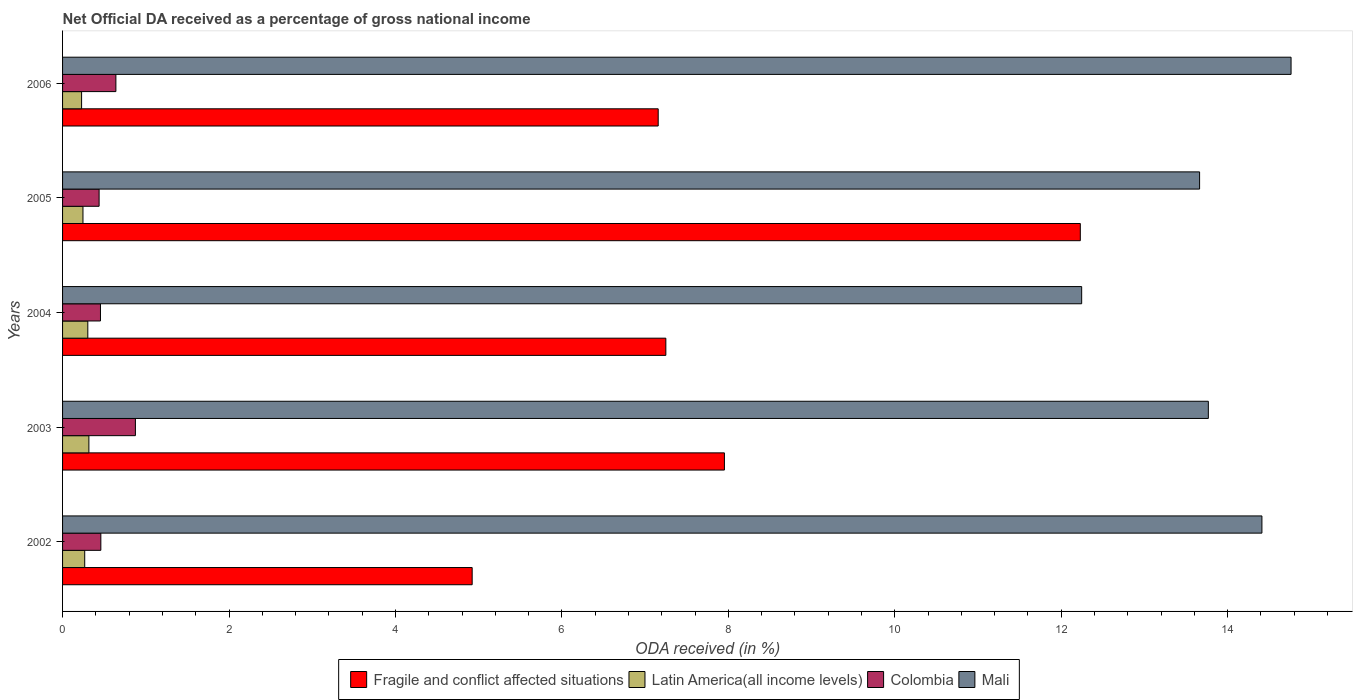Are the number of bars on each tick of the Y-axis equal?
Offer a very short reply. Yes. How many bars are there on the 2nd tick from the bottom?
Ensure brevity in your answer.  4. What is the net official DA received in Latin America(all income levels) in 2006?
Provide a succinct answer. 0.23. Across all years, what is the maximum net official DA received in Colombia?
Your answer should be compact. 0.88. Across all years, what is the minimum net official DA received in Fragile and conflict affected situations?
Provide a short and direct response. 4.92. In which year was the net official DA received in Mali maximum?
Offer a terse response. 2006. What is the total net official DA received in Fragile and conflict affected situations in the graph?
Your response must be concise. 39.51. What is the difference between the net official DA received in Fragile and conflict affected situations in 2004 and that in 2005?
Offer a very short reply. -4.98. What is the difference between the net official DA received in Mali in 2004 and the net official DA received in Fragile and conflict affected situations in 2002?
Your answer should be very brief. 7.32. What is the average net official DA received in Latin America(all income levels) per year?
Make the answer very short. 0.27. In the year 2003, what is the difference between the net official DA received in Mali and net official DA received in Colombia?
Offer a terse response. 12.89. What is the ratio of the net official DA received in Colombia in 2003 to that in 2006?
Give a very brief answer. 1.37. Is the net official DA received in Mali in 2004 less than that in 2005?
Keep it short and to the point. Yes. What is the difference between the highest and the second highest net official DA received in Latin America(all income levels)?
Make the answer very short. 0.01. What is the difference between the highest and the lowest net official DA received in Fragile and conflict affected situations?
Keep it short and to the point. 7.31. In how many years, is the net official DA received in Colombia greater than the average net official DA received in Colombia taken over all years?
Keep it short and to the point. 2. What does the 4th bar from the top in 2002 represents?
Your answer should be compact. Fragile and conflict affected situations. What does the 3rd bar from the bottom in 2002 represents?
Provide a short and direct response. Colombia. Is it the case that in every year, the sum of the net official DA received in Fragile and conflict affected situations and net official DA received in Colombia is greater than the net official DA received in Latin America(all income levels)?
Make the answer very short. Yes. How many bars are there?
Offer a very short reply. 20. Are all the bars in the graph horizontal?
Your answer should be very brief. Yes. Does the graph contain any zero values?
Keep it short and to the point. No. Where does the legend appear in the graph?
Give a very brief answer. Bottom center. How many legend labels are there?
Your answer should be very brief. 4. How are the legend labels stacked?
Offer a very short reply. Horizontal. What is the title of the graph?
Offer a terse response. Net Official DA received as a percentage of gross national income. Does "Cyprus" appear as one of the legend labels in the graph?
Offer a very short reply. No. What is the label or title of the X-axis?
Ensure brevity in your answer.  ODA received (in %). What is the ODA received (in %) of Fragile and conflict affected situations in 2002?
Make the answer very short. 4.92. What is the ODA received (in %) of Latin America(all income levels) in 2002?
Provide a succinct answer. 0.27. What is the ODA received (in %) of Colombia in 2002?
Provide a succinct answer. 0.46. What is the ODA received (in %) in Mali in 2002?
Make the answer very short. 14.41. What is the ODA received (in %) of Fragile and conflict affected situations in 2003?
Keep it short and to the point. 7.95. What is the ODA received (in %) in Latin America(all income levels) in 2003?
Your answer should be compact. 0.32. What is the ODA received (in %) of Colombia in 2003?
Provide a short and direct response. 0.88. What is the ODA received (in %) in Mali in 2003?
Keep it short and to the point. 13.77. What is the ODA received (in %) in Fragile and conflict affected situations in 2004?
Make the answer very short. 7.25. What is the ODA received (in %) in Latin America(all income levels) in 2004?
Offer a very short reply. 0.3. What is the ODA received (in %) of Colombia in 2004?
Your response must be concise. 0.46. What is the ODA received (in %) of Mali in 2004?
Offer a terse response. 12.25. What is the ODA received (in %) in Fragile and conflict affected situations in 2005?
Make the answer very short. 12.23. What is the ODA received (in %) of Latin America(all income levels) in 2005?
Your answer should be very brief. 0.25. What is the ODA received (in %) in Colombia in 2005?
Your response must be concise. 0.44. What is the ODA received (in %) in Mali in 2005?
Your answer should be very brief. 13.66. What is the ODA received (in %) of Fragile and conflict affected situations in 2006?
Your answer should be very brief. 7.16. What is the ODA received (in %) of Latin America(all income levels) in 2006?
Offer a terse response. 0.23. What is the ODA received (in %) in Colombia in 2006?
Provide a short and direct response. 0.64. What is the ODA received (in %) in Mali in 2006?
Offer a terse response. 14.76. Across all years, what is the maximum ODA received (in %) in Fragile and conflict affected situations?
Give a very brief answer. 12.23. Across all years, what is the maximum ODA received (in %) of Latin America(all income levels)?
Your response must be concise. 0.32. Across all years, what is the maximum ODA received (in %) in Colombia?
Your answer should be compact. 0.88. Across all years, what is the maximum ODA received (in %) in Mali?
Offer a very short reply. 14.76. Across all years, what is the minimum ODA received (in %) in Fragile and conflict affected situations?
Offer a terse response. 4.92. Across all years, what is the minimum ODA received (in %) of Latin America(all income levels)?
Make the answer very short. 0.23. Across all years, what is the minimum ODA received (in %) in Colombia?
Provide a succinct answer. 0.44. Across all years, what is the minimum ODA received (in %) of Mali?
Make the answer very short. 12.25. What is the total ODA received (in %) of Fragile and conflict affected situations in the graph?
Your answer should be very brief. 39.51. What is the total ODA received (in %) of Latin America(all income levels) in the graph?
Your answer should be compact. 1.36. What is the total ODA received (in %) of Colombia in the graph?
Your response must be concise. 2.87. What is the total ODA received (in %) of Mali in the graph?
Provide a succinct answer. 68.85. What is the difference between the ODA received (in %) of Fragile and conflict affected situations in 2002 and that in 2003?
Your response must be concise. -3.03. What is the difference between the ODA received (in %) of Latin America(all income levels) in 2002 and that in 2003?
Provide a succinct answer. -0.05. What is the difference between the ODA received (in %) in Colombia in 2002 and that in 2003?
Your answer should be compact. -0.42. What is the difference between the ODA received (in %) of Mali in 2002 and that in 2003?
Make the answer very short. 0.64. What is the difference between the ODA received (in %) of Fragile and conflict affected situations in 2002 and that in 2004?
Keep it short and to the point. -2.33. What is the difference between the ODA received (in %) in Latin America(all income levels) in 2002 and that in 2004?
Your answer should be very brief. -0.04. What is the difference between the ODA received (in %) of Colombia in 2002 and that in 2004?
Your answer should be very brief. 0. What is the difference between the ODA received (in %) of Mali in 2002 and that in 2004?
Provide a succinct answer. 2.17. What is the difference between the ODA received (in %) of Fragile and conflict affected situations in 2002 and that in 2005?
Keep it short and to the point. -7.31. What is the difference between the ODA received (in %) in Latin America(all income levels) in 2002 and that in 2005?
Keep it short and to the point. 0.02. What is the difference between the ODA received (in %) in Colombia in 2002 and that in 2005?
Your answer should be very brief. 0.02. What is the difference between the ODA received (in %) of Mali in 2002 and that in 2005?
Your answer should be compact. 0.75. What is the difference between the ODA received (in %) in Fragile and conflict affected situations in 2002 and that in 2006?
Keep it short and to the point. -2.24. What is the difference between the ODA received (in %) of Latin America(all income levels) in 2002 and that in 2006?
Give a very brief answer. 0.04. What is the difference between the ODA received (in %) in Colombia in 2002 and that in 2006?
Ensure brevity in your answer.  -0.18. What is the difference between the ODA received (in %) of Mali in 2002 and that in 2006?
Keep it short and to the point. -0.35. What is the difference between the ODA received (in %) in Fragile and conflict affected situations in 2003 and that in 2004?
Offer a very short reply. 0.7. What is the difference between the ODA received (in %) of Latin America(all income levels) in 2003 and that in 2004?
Keep it short and to the point. 0.01. What is the difference between the ODA received (in %) of Colombia in 2003 and that in 2004?
Offer a terse response. 0.42. What is the difference between the ODA received (in %) of Mali in 2003 and that in 2004?
Provide a succinct answer. 1.52. What is the difference between the ODA received (in %) of Fragile and conflict affected situations in 2003 and that in 2005?
Your response must be concise. -4.28. What is the difference between the ODA received (in %) in Latin America(all income levels) in 2003 and that in 2005?
Ensure brevity in your answer.  0.07. What is the difference between the ODA received (in %) in Colombia in 2003 and that in 2005?
Your response must be concise. 0.44. What is the difference between the ODA received (in %) of Mali in 2003 and that in 2005?
Provide a succinct answer. 0.11. What is the difference between the ODA received (in %) in Fragile and conflict affected situations in 2003 and that in 2006?
Make the answer very short. 0.8. What is the difference between the ODA received (in %) in Latin America(all income levels) in 2003 and that in 2006?
Make the answer very short. 0.09. What is the difference between the ODA received (in %) in Colombia in 2003 and that in 2006?
Provide a succinct answer. 0.23. What is the difference between the ODA received (in %) in Mali in 2003 and that in 2006?
Your answer should be compact. -0.99. What is the difference between the ODA received (in %) in Fragile and conflict affected situations in 2004 and that in 2005?
Ensure brevity in your answer.  -4.98. What is the difference between the ODA received (in %) of Latin America(all income levels) in 2004 and that in 2005?
Offer a terse response. 0.06. What is the difference between the ODA received (in %) of Colombia in 2004 and that in 2005?
Give a very brief answer. 0.02. What is the difference between the ODA received (in %) in Mali in 2004 and that in 2005?
Provide a short and direct response. -1.42. What is the difference between the ODA received (in %) in Fragile and conflict affected situations in 2004 and that in 2006?
Your response must be concise. 0.09. What is the difference between the ODA received (in %) of Latin America(all income levels) in 2004 and that in 2006?
Provide a succinct answer. 0.07. What is the difference between the ODA received (in %) of Colombia in 2004 and that in 2006?
Your answer should be compact. -0.19. What is the difference between the ODA received (in %) in Mali in 2004 and that in 2006?
Your answer should be compact. -2.52. What is the difference between the ODA received (in %) in Fragile and conflict affected situations in 2005 and that in 2006?
Provide a short and direct response. 5.07. What is the difference between the ODA received (in %) of Latin America(all income levels) in 2005 and that in 2006?
Keep it short and to the point. 0.02. What is the difference between the ODA received (in %) in Colombia in 2005 and that in 2006?
Offer a terse response. -0.2. What is the difference between the ODA received (in %) of Mali in 2005 and that in 2006?
Provide a succinct answer. -1.1. What is the difference between the ODA received (in %) in Fragile and conflict affected situations in 2002 and the ODA received (in %) in Latin America(all income levels) in 2003?
Your answer should be compact. 4.61. What is the difference between the ODA received (in %) of Fragile and conflict affected situations in 2002 and the ODA received (in %) of Colombia in 2003?
Your answer should be very brief. 4.05. What is the difference between the ODA received (in %) of Fragile and conflict affected situations in 2002 and the ODA received (in %) of Mali in 2003?
Provide a succinct answer. -8.85. What is the difference between the ODA received (in %) of Latin America(all income levels) in 2002 and the ODA received (in %) of Colombia in 2003?
Your response must be concise. -0.61. What is the difference between the ODA received (in %) of Latin America(all income levels) in 2002 and the ODA received (in %) of Mali in 2003?
Your answer should be very brief. -13.5. What is the difference between the ODA received (in %) of Colombia in 2002 and the ODA received (in %) of Mali in 2003?
Your answer should be very brief. -13.31. What is the difference between the ODA received (in %) of Fragile and conflict affected situations in 2002 and the ODA received (in %) of Latin America(all income levels) in 2004?
Offer a terse response. 4.62. What is the difference between the ODA received (in %) in Fragile and conflict affected situations in 2002 and the ODA received (in %) in Colombia in 2004?
Your response must be concise. 4.47. What is the difference between the ODA received (in %) of Fragile and conflict affected situations in 2002 and the ODA received (in %) of Mali in 2004?
Your answer should be very brief. -7.32. What is the difference between the ODA received (in %) in Latin America(all income levels) in 2002 and the ODA received (in %) in Colombia in 2004?
Ensure brevity in your answer.  -0.19. What is the difference between the ODA received (in %) in Latin America(all income levels) in 2002 and the ODA received (in %) in Mali in 2004?
Make the answer very short. -11.98. What is the difference between the ODA received (in %) of Colombia in 2002 and the ODA received (in %) of Mali in 2004?
Make the answer very short. -11.79. What is the difference between the ODA received (in %) of Fragile and conflict affected situations in 2002 and the ODA received (in %) of Latin America(all income levels) in 2005?
Offer a terse response. 4.68. What is the difference between the ODA received (in %) in Fragile and conflict affected situations in 2002 and the ODA received (in %) in Colombia in 2005?
Give a very brief answer. 4.48. What is the difference between the ODA received (in %) in Fragile and conflict affected situations in 2002 and the ODA received (in %) in Mali in 2005?
Provide a succinct answer. -8.74. What is the difference between the ODA received (in %) in Latin America(all income levels) in 2002 and the ODA received (in %) in Colombia in 2005?
Ensure brevity in your answer.  -0.17. What is the difference between the ODA received (in %) in Latin America(all income levels) in 2002 and the ODA received (in %) in Mali in 2005?
Keep it short and to the point. -13.4. What is the difference between the ODA received (in %) in Colombia in 2002 and the ODA received (in %) in Mali in 2005?
Your answer should be compact. -13.2. What is the difference between the ODA received (in %) in Fragile and conflict affected situations in 2002 and the ODA received (in %) in Latin America(all income levels) in 2006?
Your answer should be compact. 4.69. What is the difference between the ODA received (in %) in Fragile and conflict affected situations in 2002 and the ODA received (in %) in Colombia in 2006?
Offer a very short reply. 4.28. What is the difference between the ODA received (in %) of Fragile and conflict affected situations in 2002 and the ODA received (in %) of Mali in 2006?
Your answer should be compact. -9.84. What is the difference between the ODA received (in %) of Latin America(all income levels) in 2002 and the ODA received (in %) of Colombia in 2006?
Make the answer very short. -0.37. What is the difference between the ODA received (in %) in Latin America(all income levels) in 2002 and the ODA received (in %) in Mali in 2006?
Provide a short and direct response. -14.5. What is the difference between the ODA received (in %) in Colombia in 2002 and the ODA received (in %) in Mali in 2006?
Offer a terse response. -14.3. What is the difference between the ODA received (in %) of Fragile and conflict affected situations in 2003 and the ODA received (in %) of Latin America(all income levels) in 2004?
Your answer should be very brief. 7.65. What is the difference between the ODA received (in %) of Fragile and conflict affected situations in 2003 and the ODA received (in %) of Colombia in 2004?
Your answer should be very brief. 7.5. What is the difference between the ODA received (in %) in Fragile and conflict affected situations in 2003 and the ODA received (in %) in Mali in 2004?
Make the answer very short. -4.29. What is the difference between the ODA received (in %) of Latin America(all income levels) in 2003 and the ODA received (in %) of Colombia in 2004?
Ensure brevity in your answer.  -0.14. What is the difference between the ODA received (in %) in Latin America(all income levels) in 2003 and the ODA received (in %) in Mali in 2004?
Your answer should be compact. -11.93. What is the difference between the ODA received (in %) of Colombia in 2003 and the ODA received (in %) of Mali in 2004?
Your answer should be compact. -11.37. What is the difference between the ODA received (in %) in Fragile and conflict affected situations in 2003 and the ODA received (in %) in Latin America(all income levels) in 2005?
Provide a succinct answer. 7.71. What is the difference between the ODA received (in %) in Fragile and conflict affected situations in 2003 and the ODA received (in %) in Colombia in 2005?
Offer a terse response. 7.51. What is the difference between the ODA received (in %) of Fragile and conflict affected situations in 2003 and the ODA received (in %) of Mali in 2005?
Your response must be concise. -5.71. What is the difference between the ODA received (in %) of Latin America(all income levels) in 2003 and the ODA received (in %) of Colombia in 2005?
Provide a succinct answer. -0.12. What is the difference between the ODA received (in %) of Latin America(all income levels) in 2003 and the ODA received (in %) of Mali in 2005?
Ensure brevity in your answer.  -13.35. What is the difference between the ODA received (in %) in Colombia in 2003 and the ODA received (in %) in Mali in 2005?
Keep it short and to the point. -12.79. What is the difference between the ODA received (in %) of Fragile and conflict affected situations in 2003 and the ODA received (in %) of Latin America(all income levels) in 2006?
Ensure brevity in your answer.  7.72. What is the difference between the ODA received (in %) of Fragile and conflict affected situations in 2003 and the ODA received (in %) of Colombia in 2006?
Your response must be concise. 7.31. What is the difference between the ODA received (in %) in Fragile and conflict affected situations in 2003 and the ODA received (in %) in Mali in 2006?
Ensure brevity in your answer.  -6.81. What is the difference between the ODA received (in %) in Latin America(all income levels) in 2003 and the ODA received (in %) in Colombia in 2006?
Ensure brevity in your answer.  -0.32. What is the difference between the ODA received (in %) in Latin America(all income levels) in 2003 and the ODA received (in %) in Mali in 2006?
Your answer should be compact. -14.45. What is the difference between the ODA received (in %) in Colombia in 2003 and the ODA received (in %) in Mali in 2006?
Your answer should be very brief. -13.89. What is the difference between the ODA received (in %) of Fragile and conflict affected situations in 2004 and the ODA received (in %) of Latin America(all income levels) in 2005?
Offer a terse response. 7. What is the difference between the ODA received (in %) in Fragile and conflict affected situations in 2004 and the ODA received (in %) in Colombia in 2005?
Provide a short and direct response. 6.81. What is the difference between the ODA received (in %) in Fragile and conflict affected situations in 2004 and the ODA received (in %) in Mali in 2005?
Your response must be concise. -6.41. What is the difference between the ODA received (in %) of Latin America(all income levels) in 2004 and the ODA received (in %) of Colombia in 2005?
Your answer should be compact. -0.14. What is the difference between the ODA received (in %) in Latin America(all income levels) in 2004 and the ODA received (in %) in Mali in 2005?
Your answer should be very brief. -13.36. What is the difference between the ODA received (in %) in Colombia in 2004 and the ODA received (in %) in Mali in 2005?
Your answer should be very brief. -13.21. What is the difference between the ODA received (in %) of Fragile and conflict affected situations in 2004 and the ODA received (in %) of Latin America(all income levels) in 2006?
Provide a short and direct response. 7.02. What is the difference between the ODA received (in %) of Fragile and conflict affected situations in 2004 and the ODA received (in %) of Colombia in 2006?
Provide a short and direct response. 6.61. What is the difference between the ODA received (in %) in Fragile and conflict affected situations in 2004 and the ODA received (in %) in Mali in 2006?
Keep it short and to the point. -7.51. What is the difference between the ODA received (in %) of Latin America(all income levels) in 2004 and the ODA received (in %) of Colombia in 2006?
Make the answer very short. -0.34. What is the difference between the ODA received (in %) of Latin America(all income levels) in 2004 and the ODA received (in %) of Mali in 2006?
Provide a succinct answer. -14.46. What is the difference between the ODA received (in %) of Colombia in 2004 and the ODA received (in %) of Mali in 2006?
Keep it short and to the point. -14.31. What is the difference between the ODA received (in %) of Fragile and conflict affected situations in 2005 and the ODA received (in %) of Latin America(all income levels) in 2006?
Make the answer very short. 12. What is the difference between the ODA received (in %) of Fragile and conflict affected situations in 2005 and the ODA received (in %) of Colombia in 2006?
Offer a very short reply. 11.59. What is the difference between the ODA received (in %) in Fragile and conflict affected situations in 2005 and the ODA received (in %) in Mali in 2006?
Keep it short and to the point. -2.53. What is the difference between the ODA received (in %) in Latin America(all income levels) in 2005 and the ODA received (in %) in Colombia in 2006?
Give a very brief answer. -0.4. What is the difference between the ODA received (in %) in Latin America(all income levels) in 2005 and the ODA received (in %) in Mali in 2006?
Ensure brevity in your answer.  -14.52. What is the difference between the ODA received (in %) in Colombia in 2005 and the ODA received (in %) in Mali in 2006?
Offer a terse response. -14.32. What is the average ODA received (in %) of Fragile and conflict affected situations per year?
Offer a very short reply. 7.9. What is the average ODA received (in %) in Latin America(all income levels) per year?
Your answer should be very brief. 0.27. What is the average ODA received (in %) in Colombia per year?
Your response must be concise. 0.57. What is the average ODA received (in %) in Mali per year?
Your answer should be very brief. 13.77. In the year 2002, what is the difference between the ODA received (in %) of Fragile and conflict affected situations and ODA received (in %) of Latin America(all income levels)?
Make the answer very short. 4.66. In the year 2002, what is the difference between the ODA received (in %) of Fragile and conflict affected situations and ODA received (in %) of Colombia?
Give a very brief answer. 4.46. In the year 2002, what is the difference between the ODA received (in %) in Fragile and conflict affected situations and ODA received (in %) in Mali?
Your answer should be compact. -9.49. In the year 2002, what is the difference between the ODA received (in %) in Latin America(all income levels) and ODA received (in %) in Colombia?
Provide a succinct answer. -0.19. In the year 2002, what is the difference between the ODA received (in %) of Latin America(all income levels) and ODA received (in %) of Mali?
Offer a very short reply. -14.14. In the year 2002, what is the difference between the ODA received (in %) of Colombia and ODA received (in %) of Mali?
Make the answer very short. -13.95. In the year 2003, what is the difference between the ODA received (in %) of Fragile and conflict affected situations and ODA received (in %) of Latin America(all income levels)?
Provide a succinct answer. 7.64. In the year 2003, what is the difference between the ODA received (in %) in Fragile and conflict affected situations and ODA received (in %) in Colombia?
Provide a succinct answer. 7.08. In the year 2003, what is the difference between the ODA received (in %) in Fragile and conflict affected situations and ODA received (in %) in Mali?
Make the answer very short. -5.81. In the year 2003, what is the difference between the ODA received (in %) in Latin America(all income levels) and ODA received (in %) in Colombia?
Your response must be concise. -0.56. In the year 2003, what is the difference between the ODA received (in %) in Latin America(all income levels) and ODA received (in %) in Mali?
Your response must be concise. -13.45. In the year 2003, what is the difference between the ODA received (in %) in Colombia and ODA received (in %) in Mali?
Offer a very short reply. -12.89. In the year 2004, what is the difference between the ODA received (in %) of Fragile and conflict affected situations and ODA received (in %) of Latin America(all income levels)?
Give a very brief answer. 6.95. In the year 2004, what is the difference between the ODA received (in %) of Fragile and conflict affected situations and ODA received (in %) of Colombia?
Offer a terse response. 6.79. In the year 2004, what is the difference between the ODA received (in %) of Fragile and conflict affected situations and ODA received (in %) of Mali?
Keep it short and to the point. -5. In the year 2004, what is the difference between the ODA received (in %) of Latin America(all income levels) and ODA received (in %) of Colombia?
Your response must be concise. -0.15. In the year 2004, what is the difference between the ODA received (in %) of Latin America(all income levels) and ODA received (in %) of Mali?
Ensure brevity in your answer.  -11.94. In the year 2004, what is the difference between the ODA received (in %) in Colombia and ODA received (in %) in Mali?
Provide a succinct answer. -11.79. In the year 2005, what is the difference between the ODA received (in %) of Fragile and conflict affected situations and ODA received (in %) of Latin America(all income levels)?
Give a very brief answer. 11.98. In the year 2005, what is the difference between the ODA received (in %) of Fragile and conflict affected situations and ODA received (in %) of Colombia?
Offer a terse response. 11.79. In the year 2005, what is the difference between the ODA received (in %) in Fragile and conflict affected situations and ODA received (in %) in Mali?
Your answer should be compact. -1.43. In the year 2005, what is the difference between the ODA received (in %) of Latin America(all income levels) and ODA received (in %) of Colombia?
Ensure brevity in your answer.  -0.19. In the year 2005, what is the difference between the ODA received (in %) in Latin America(all income levels) and ODA received (in %) in Mali?
Your answer should be very brief. -13.42. In the year 2005, what is the difference between the ODA received (in %) in Colombia and ODA received (in %) in Mali?
Give a very brief answer. -13.22. In the year 2006, what is the difference between the ODA received (in %) in Fragile and conflict affected situations and ODA received (in %) in Latin America(all income levels)?
Provide a short and direct response. 6.93. In the year 2006, what is the difference between the ODA received (in %) of Fragile and conflict affected situations and ODA received (in %) of Colombia?
Your answer should be compact. 6.52. In the year 2006, what is the difference between the ODA received (in %) of Fragile and conflict affected situations and ODA received (in %) of Mali?
Offer a very short reply. -7.6. In the year 2006, what is the difference between the ODA received (in %) in Latin America(all income levels) and ODA received (in %) in Colombia?
Your answer should be compact. -0.41. In the year 2006, what is the difference between the ODA received (in %) of Latin America(all income levels) and ODA received (in %) of Mali?
Your answer should be compact. -14.53. In the year 2006, what is the difference between the ODA received (in %) of Colombia and ODA received (in %) of Mali?
Your answer should be compact. -14.12. What is the ratio of the ODA received (in %) in Fragile and conflict affected situations in 2002 to that in 2003?
Offer a very short reply. 0.62. What is the ratio of the ODA received (in %) in Latin America(all income levels) in 2002 to that in 2003?
Offer a terse response. 0.84. What is the ratio of the ODA received (in %) of Colombia in 2002 to that in 2003?
Provide a succinct answer. 0.53. What is the ratio of the ODA received (in %) in Mali in 2002 to that in 2003?
Offer a very short reply. 1.05. What is the ratio of the ODA received (in %) in Fragile and conflict affected situations in 2002 to that in 2004?
Ensure brevity in your answer.  0.68. What is the ratio of the ODA received (in %) of Latin America(all income levels) in 2002 to that in 2004?
Offer a terse response. 0.88. What is the ratio of the ODA received (in %) of Mali in 2002 to that in 2004?
Ensure brevity in your answer.  1.18. What is the ratio of the ODA received (in %) of Fragile and conflict affected situations in 2002 to that in 2005?
Your answer should be compact. 0.4. What is the ratio of the ODA received (in %) of Latin America(all income levels) in 2002 to that in 2005?
Make the answer very short. 1.09. What is the ratio of the ODA received (in %) in Colombia in 2002 to that in 2005?
Your answer should be very brief. 1.05. What is the ratio of the ODA received (in %) in Mali in 2002 to that in 2005?
Your answer should be very brief. 1.05. What is the ratio of the ODA received (in %) of Fragile and conflict affected situations in 2002 to that in 2006?
Your answer should be compact. 0.69. What is the ratio of the ODA received (in %) in Latin America(all income levels) in 2002 to that in 2006?
Offer a terse response. 1.16. What is the ratio of the ODA received (in %) in Colombia in 2002 to that in 2006?
Give a very brief answer. 0.72. What is the ratio of the ODA received (in %) of Mali in 2002 to that in 2006?
Make the answer very short. 0.98. What is the ratio of the ODA received (in %) of Fragile and conflict affected situations in 2003 to that in 2004?
Offer a very short reply. 1.1. What is the ratio of the ODA received (in %) of Latin America(all income levels) in 2003 to that in 2004?
Keep it short and to the point. 1.04. What is the ratio of the ODA received (in %) of Colombia in 2003 to that in 2004?
Provide a succinct answer. 1.92. What is the ratio of the ODA received (in %) in Mali in 2003 to that in 2004?
Your answer should be very brief. 1.12. What is the ratio of the ODA received (in %) in Fragile and conflict affected situations in 2003 to that in 2005?
Offer a terse response. 0.65. What is the ratio of the ODA received (in %) in Latin America(all income levels) in 2003 to that in 2005?
Ensure brevity in your answer.  1.29. What is the ratio of the ODA received (in %) of Colombia in 2003 to that in 2005?
Ensure brevity in your answer.  1.99. What is the ratio of the ODA received (in %) in Mali in 2003 to that in 2005?
Ensure brevity in your answer.  1.01. What is the ratio of the ODA received (in %) of Fragile and conflict affected situations in 2003 to that in 2006?
Offer a terse response. 1.11. What is the ratio of the ODA received (in %) of Latin America(all income levels) in 2003 to that in 2006?
Give a very brief answer. 1.38. What is the ratio of the ODA received (in %) of Colombia in 2003 to that in 2006?
Make the answer very short. 1.37. What is the ratio of the ODA received (in %) in Mali in 2003 to that in 2006?
Offer a terse response. 0.93. What is the ratio of the ODA received (in %) of Fragile and conflict affected situations in 2004 to that in 2005?
Provide a succinct answer. 0.59. What is the ratio of the ODA received (in %) of Latin America(all income levels) in 2004 to that in 2005?
Your answer should be compact. 1.24. What is the ratio of the ODA received (in %) of Colombia in 2004 to that in 2005?
Your response must be concise. 1.04. What is the ratio of the ODA received (in %) of Mali in 2004 to that in 2005?
Offer a terse response. 0.9. What is the ratio of the ODA received (in %) of Fragile and conflict affected situations in 2004 to that in 2006?
Provide a succinct answer. 1.01. What is the ratio of the ODA received (in %) of Latin America(all income levels) in 2004 to that in 2006?
Your answer should be compact. 1.33. What is the ratio of the ODA received (in %) in Colombia in 2004 to that in 2006?
Your answer should be very brief. 0.71. What is the ratio of the ODA received (in %) in Mali in 2004 to that in 2006?
Ensure brevity in your answer.  0.83. What is the ratio of the ODA received (in %) in Fragile and conflict affected situations in 2005 to that in 2006?
Provide a succinct answer. 1.71. What is the ratio of the ODA received (in %) in Latin America(all income levels) in 2005 to that in 2006?
Offer a very short reply. 1.07. What is the ratio of the ODA received (in %) of Colombia in 2005 to that in 2006?
Provide a short and direct response. 0.69. What is the ratio of the ODA received (in %) in Mali in 2005 to that in 2006?
Your response must be concise. 0.93. What is the difference between the highest and the second highest ODA received (in %) of Fragile and conflict affected situations?
Offer a terse response. 4.28. What is the difference between the highest and the second highest ODA received (in %) in Latin America(all income levels)?
Your answer should be very brief. 0.01. What is the difference between the highest and the second highest ODA received (in %) in Colombia?
Your response must be concise. 0.23. What is the difference between the highest and the second highest ODA received (in %) of Mali?
Your answer should be very brief. 0.35. What is the difference between the highest and the lowest ODA received (in %) in Fragile and conflict affected situations?
Give a very brief answer. 7.31. What is the difference between the highest and the lowest ODA received (in %) in Latin America(all income levels)?
Your answer should be compact. 0.09. What is the difference between the highest and the lowest ODA received (in %) in Colombia?
Give a very brief answer. 0.44. What is the difference between the highest and the lowest ODA received (in %) in Mali?
Your answer should be compact. 2.52. 